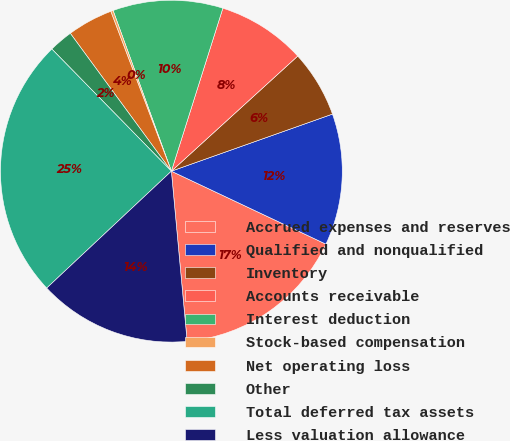Convert chart to OTSL. <chart><loc_0><loc_0><loc_500><loc_500><pie_chart><fcel>Accrued expenses and reserves<fcel>Qualified and nonqualified<fcel>Inventory<fcel>Accounts receivable<fcel>Interest deduction<fcel>Stock-based compensation<fcel>Net operating loss<fcel>Other<fcel>Total deferred tax assets<fcel>Less valuation allowance<nl><fcel>16.51%<fcel>12.44%<fcel>6.34%<fcel>8.37%<fcel>10.41%<fcel>0.23%<fcel>4.3%<fcel>2.26%<fcel>24.66%<fcel>14.48%<nl></chart> 